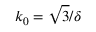Convert formula to latex. <formula><loc_0><loc_0><loc_500><loc_500>k _ { 0 } = \sqrt { 3 } / \delta</formula> 